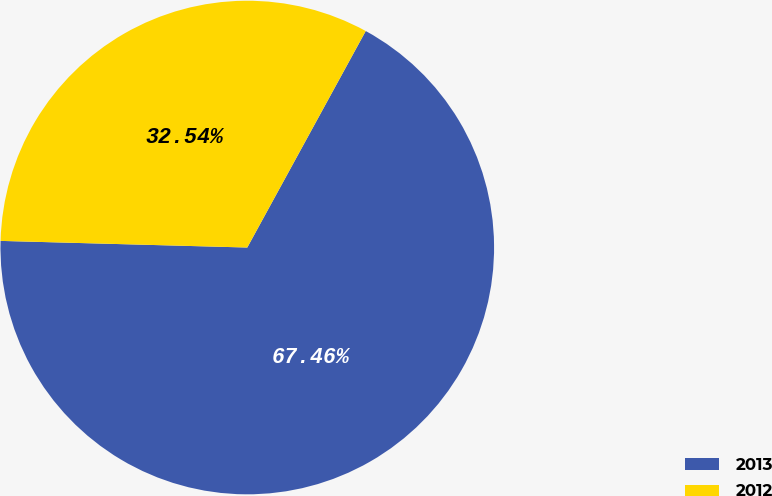Convert chart to OTSL. <chart><loc_0><loc_0><loc_500><loc_500><pie_chart><fcel>2013<fcel>2012<nl><fcel>67.46%<fcel>32.54%<nl></chart> 